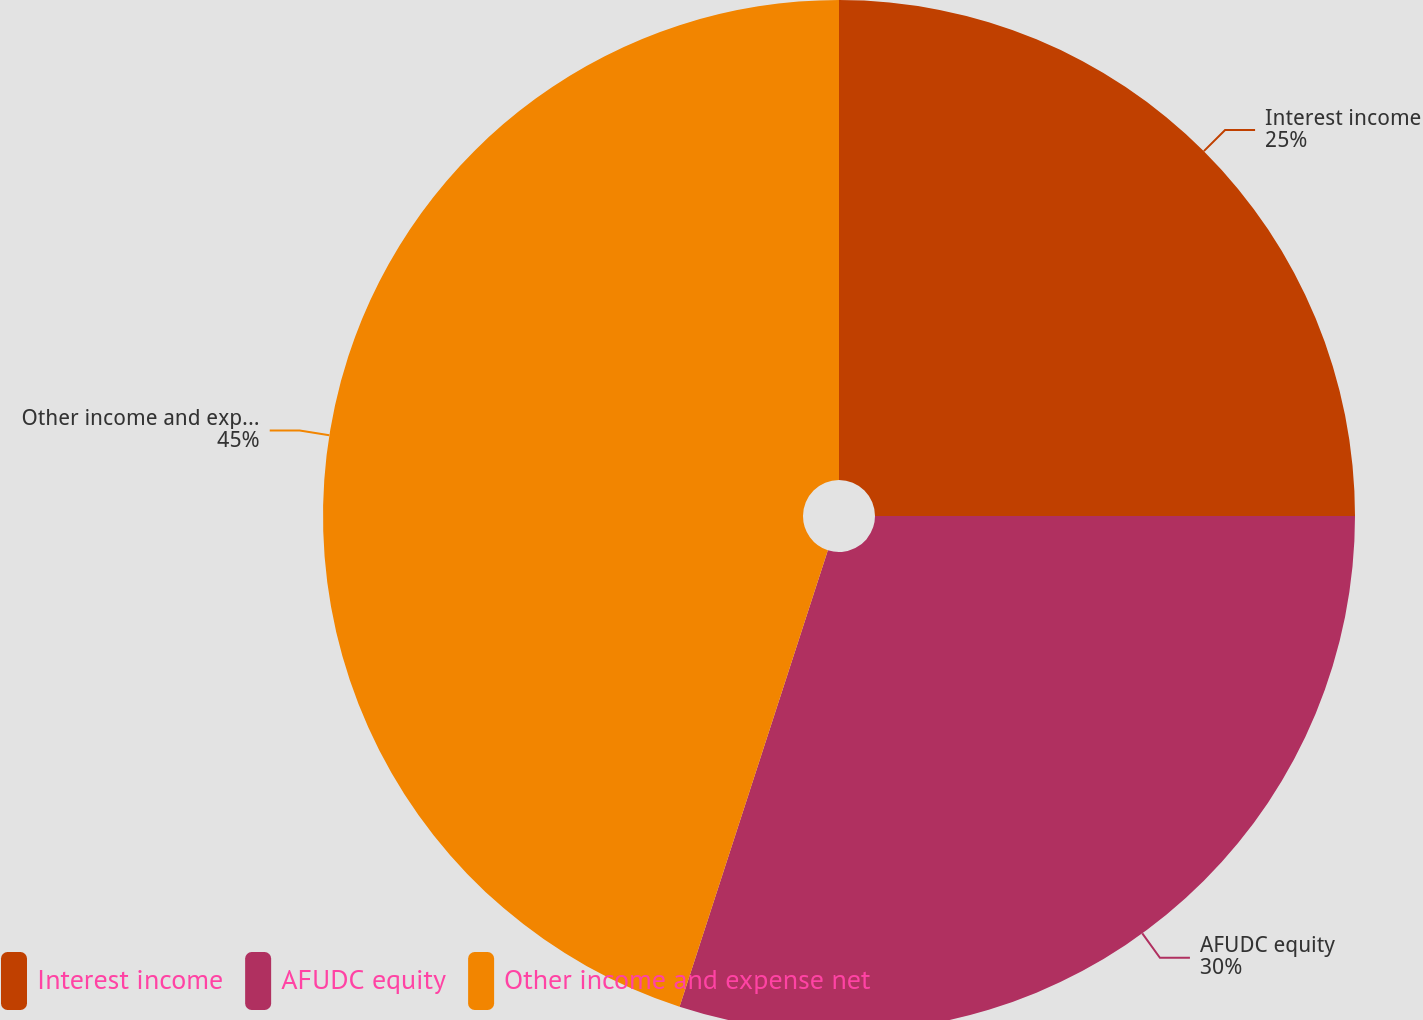Convert chart to OTSL. <chart><loc_0><loc_0><loc_500><loc_500><pie_chart><fcel>Interest income<fcel>AFUDC equity<fcel>Other income and expense net<nl><fcel>25.0%<fcel>30.0%<fcel>45.0%<nl></chart> 